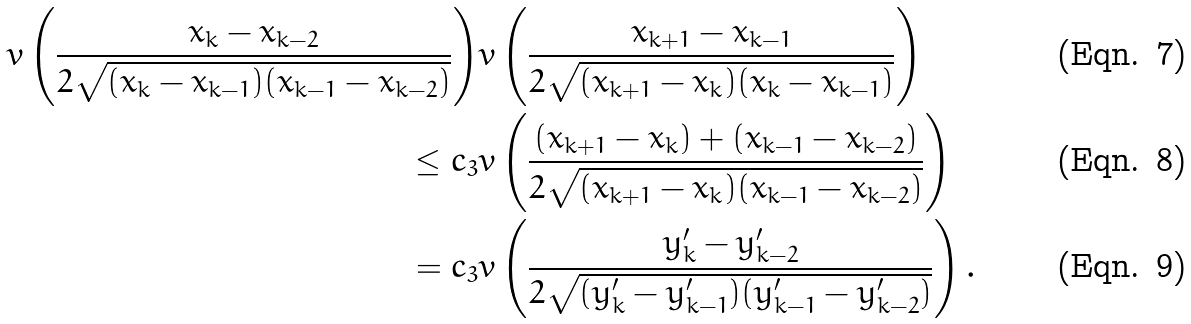Convert formula to latex. <formula><loc_0><loc_0><loc_500><loc_500>v \left ( \frac { x _ { k } - x _ { k - 2 } } { 2 \sqrt { ( x _ { k } - x _ { k - 1 } ) ( x _ { k - 1 } - x _ { k - 2 } ) } } \right ) & v \left ( \frac { x _ { k + 1 } - x _ { k - 1 } } { 2 \sqrt { ( x _ { k + 1 } - x _ { k } ) ( x _ { k } - x _ { k - 1 } ) } } \right ) \\ \leq c _ { 3 } & v \left ( \frac { ( x _ { k + 1 } - x _ { k } ) + ( x _ { k - 1 } - x _ { k - 2 } ) } { 2 \sqrt { ( x _ { k + 1 } - x _ { k } ) ( x _ { k - 1 } - x _ { k - 2 } ) } } \right ) \\ = c _ { 3 } & v \left ( \frac { y ^ { \prime } _ { k } - y ^ { \prime } _ { k - 2 } } { 2 \sqrt { ( y ^ { \prime } _ { k } - y ^ { \prime } _ { k - 1 } ) ( y ^ { \prime } _ { k - 1 } - y ^ { \prime } _ { k - 2 } ) } } \right ) .</formula> 